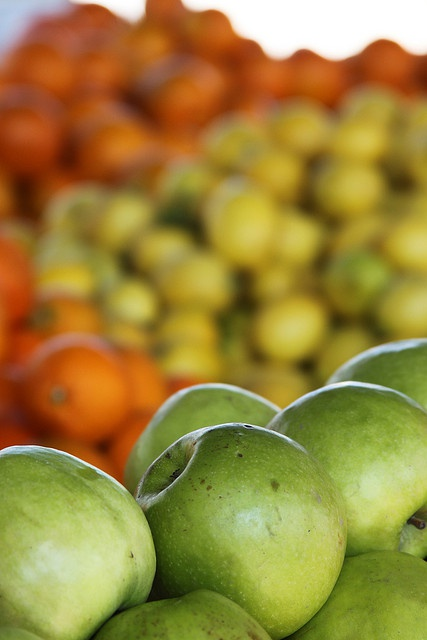Describe the objects in this image and their specific colors. I can see orange in lightblue, brown, maroon, and red tones, apple in lightblue, darkgreen, khaki, and olive tones, apple in lightblue, olive, and khaki tones, orange in lightblue, red, and maroon tones, and apple in lightblue, darkgreen, and olive tones in this image. 